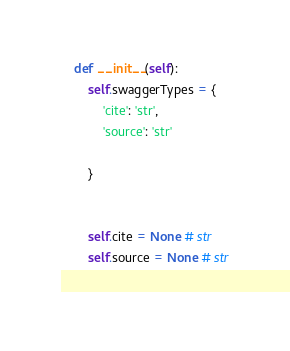Convert code to text. <code><loc_0><loc_0><loc_500><loc_500><_Python_>
    def __init__(self):
        self.swaggerTypes = {
            'cite': 'str',
            'source': 'str'

        }


        self.cite = None # str
        self.source = None # str
        
</code> 